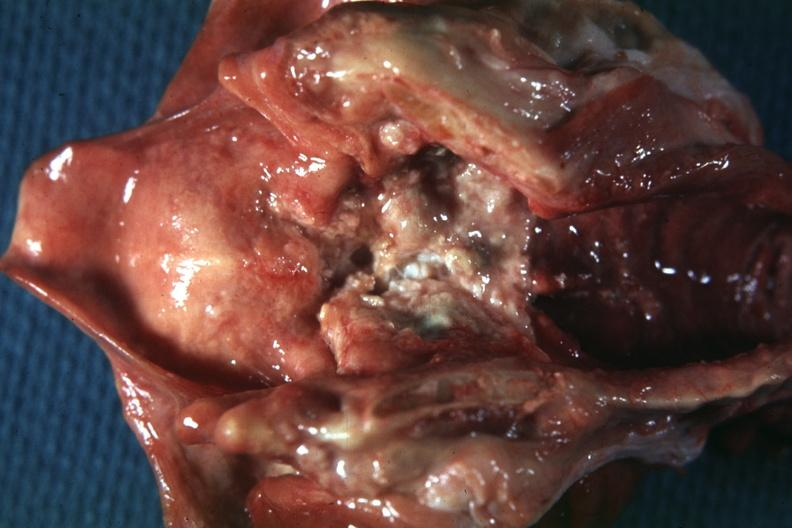s squamous cell carcinoma present?
Answer the question using a single word or phrase. Yes 